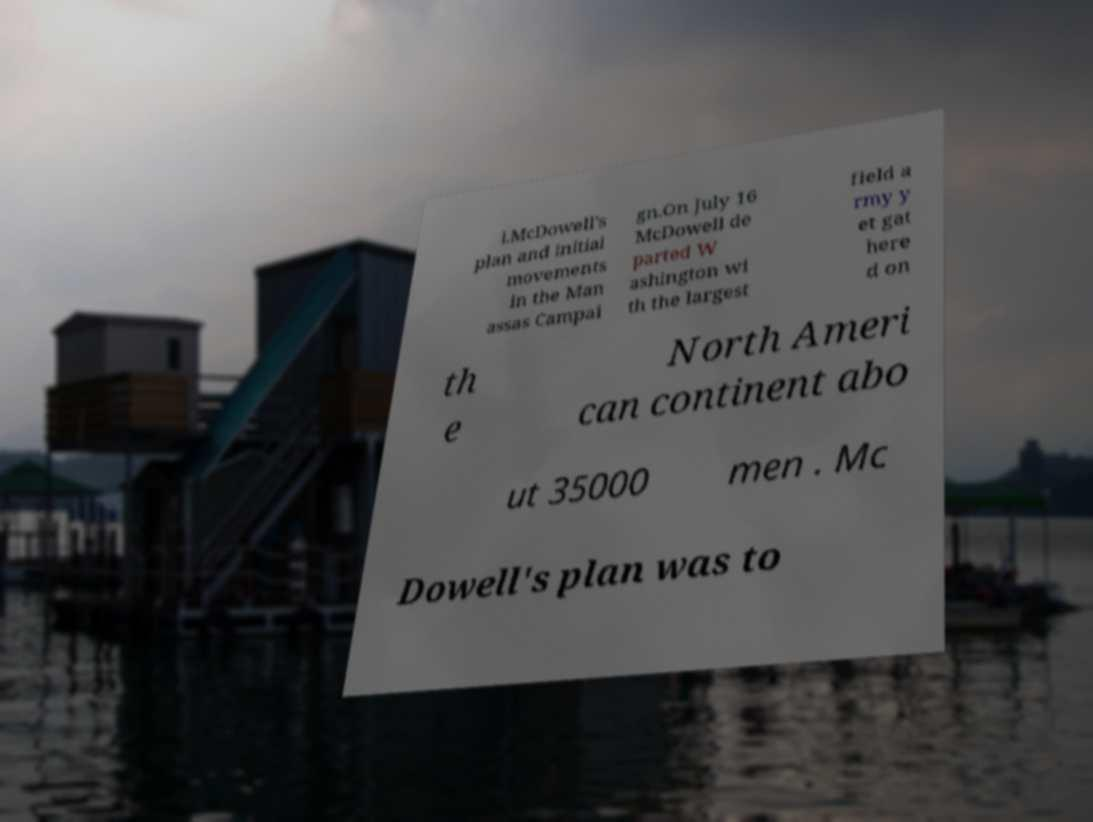Please identify and transcribe the text found in this image. l.McDowell's plan and initial movements in the Man assas Campai gn.On July 16 McDowell de parted W ashington wi th the largest field a rmy y et gat here d on th e North Ameri can continent abo ut 35000 men . Mc Dowell's plan was to 